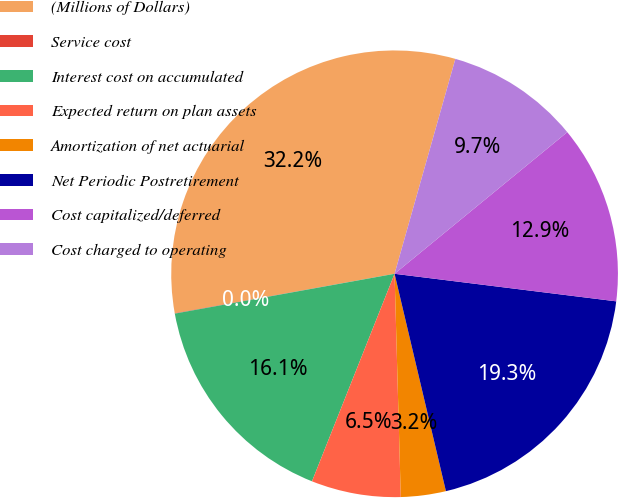<chart> <loc_0><loc_0><loc_500><loc_500><pie_chart><fcel>(Millions of Dollars)<fcel>Service cost<fcel>Interest cost on accumulated<fcel>Expected return on plan assets<fcel>Amortization of net actuarial<fcel>Net Periodic Postretirement<fcel>Cost capitalized/deferred<fcel>Cost charged to operating<nl><fcel>32.21%<fcel>0.03%<fcel>16.12%<fcel>6.47%<fcel>3.25%<fcel>19.34%<fcel>12.9%<fcel>9.68%<nl></chart> 